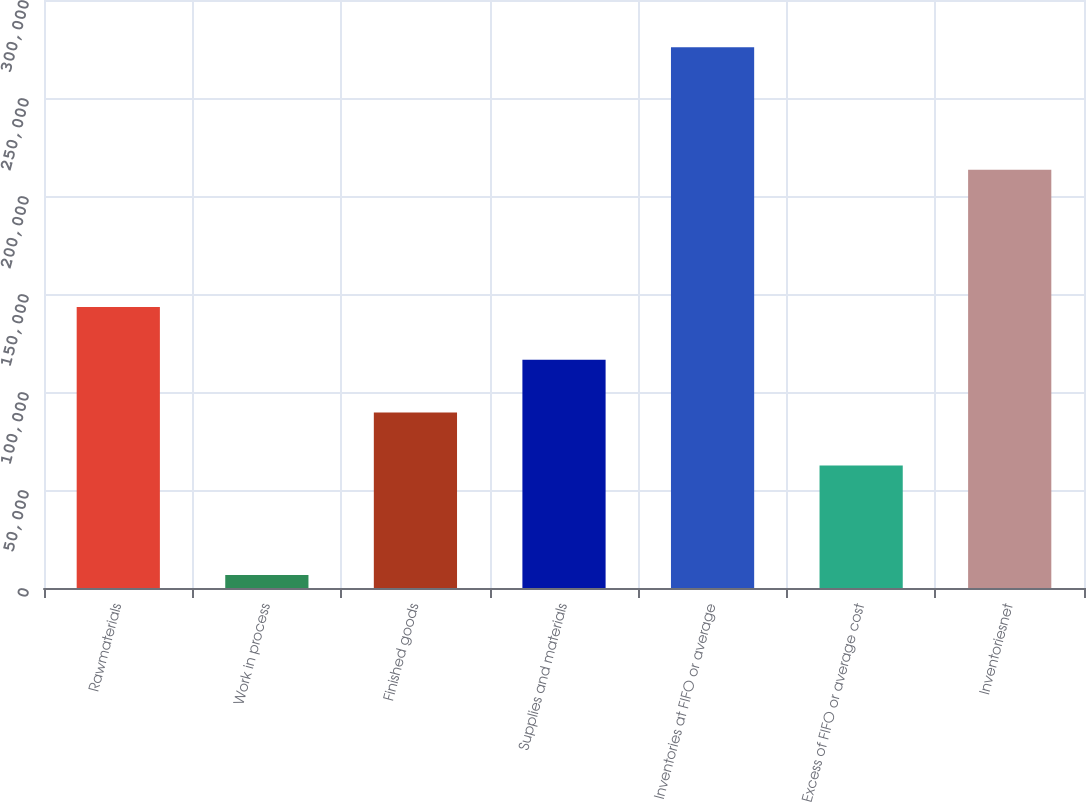<chart> <loc_0><loc_0><loc_500><loc_500><bar_chart><fcel>Rawmaterials<fcel>Work in process<fcel>Finished goods<fcel>Supplies and materials<fcel>Inventories at FIFO or average<fcel>Excess of FIFO or average cost<fcel>Inventoriesnet<nl><fcel>143349<fcel>6600<fcel>89480.2<fcel>116414<fcel>275942<fcel>62546<fcel>213396<nl></chart> 